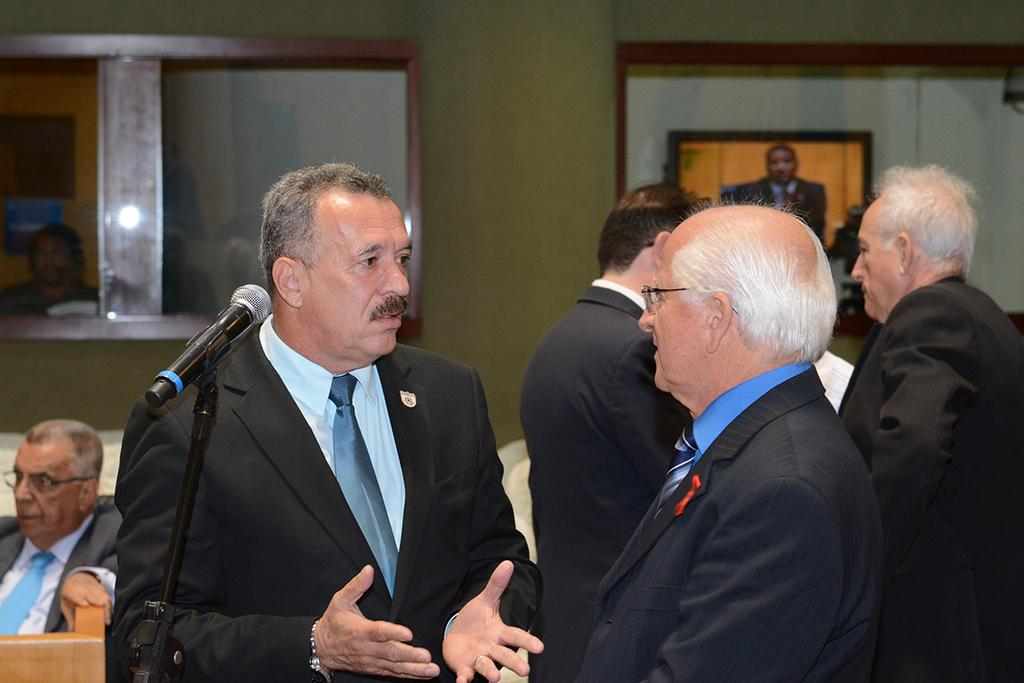How many people are present in the image? There are 4 people standing in the image. What are the people wearing? The people are wearing suits. What object is at the front of the image? There is a microphone at the front of the image. Can you describe the position of the person sitting in the image? A person is sitting at the left back of the image. What can be seen at the back of the image? There are windows at the back of the image. What type of lunchroom is visible in the image? There is no lunchroom present in the image. What color is the orange being used by the people in the image? There is no orange present in the image. 